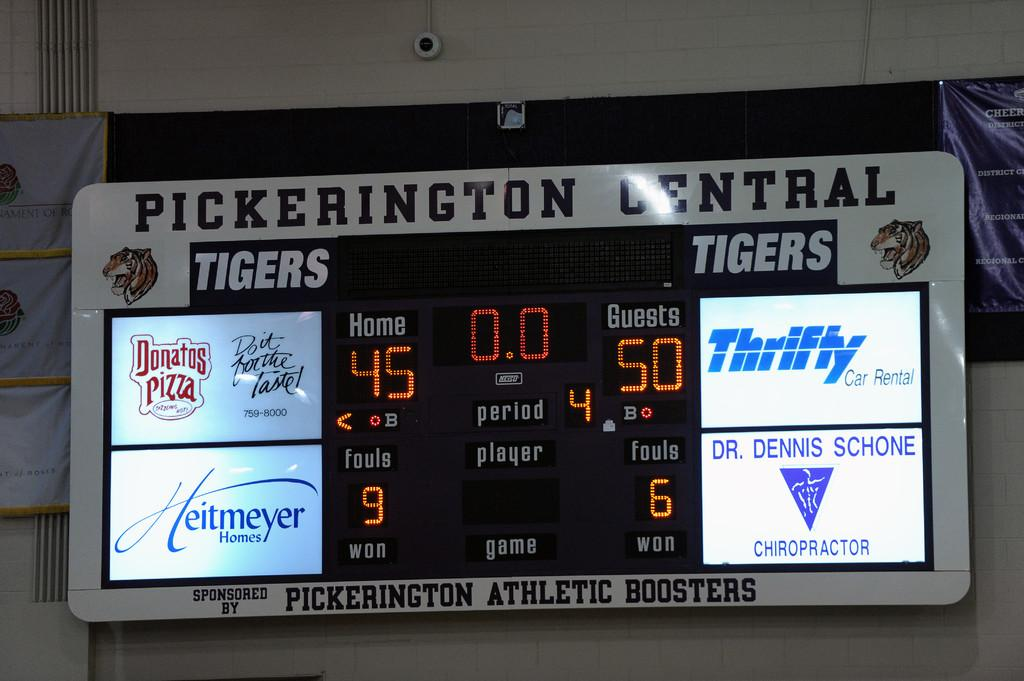<image>
Relay a brief, clear account of the picture shown. a scoreboard that had the numbers 45 and 50 on it 